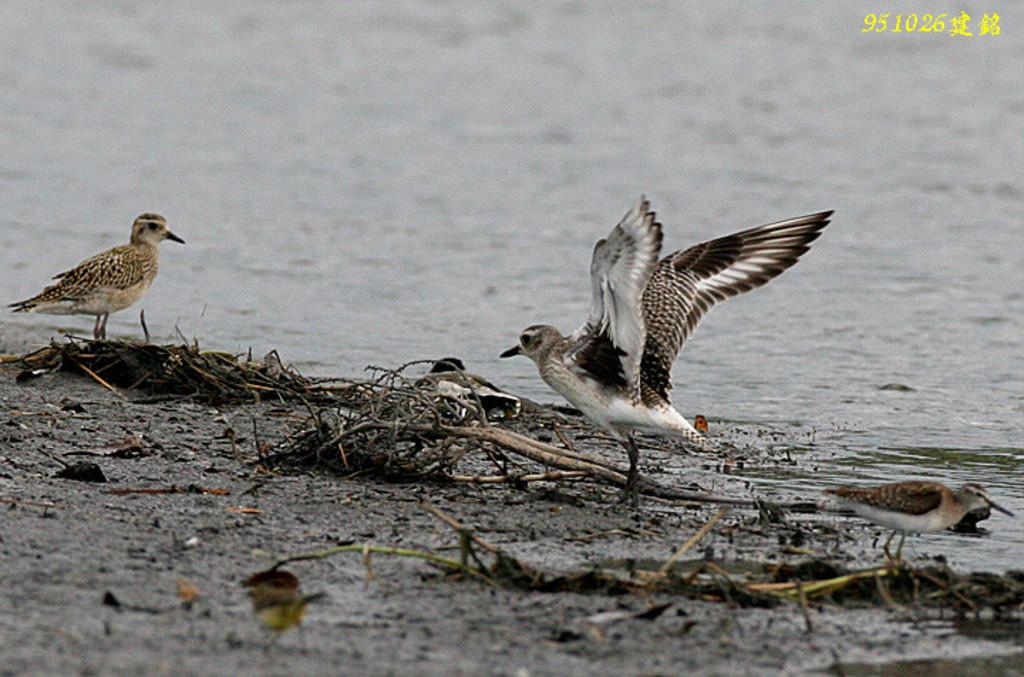How many birds are present in the image? There are three birds in the image. What is visible in the image besides the birds? Water is visible in the image. Can you describe the background of the image? The background of the image is blurred. What type of tool does the carpenter use in the image? There is no carpenter present in the image, so it is not possible to determine what tools they might use. 